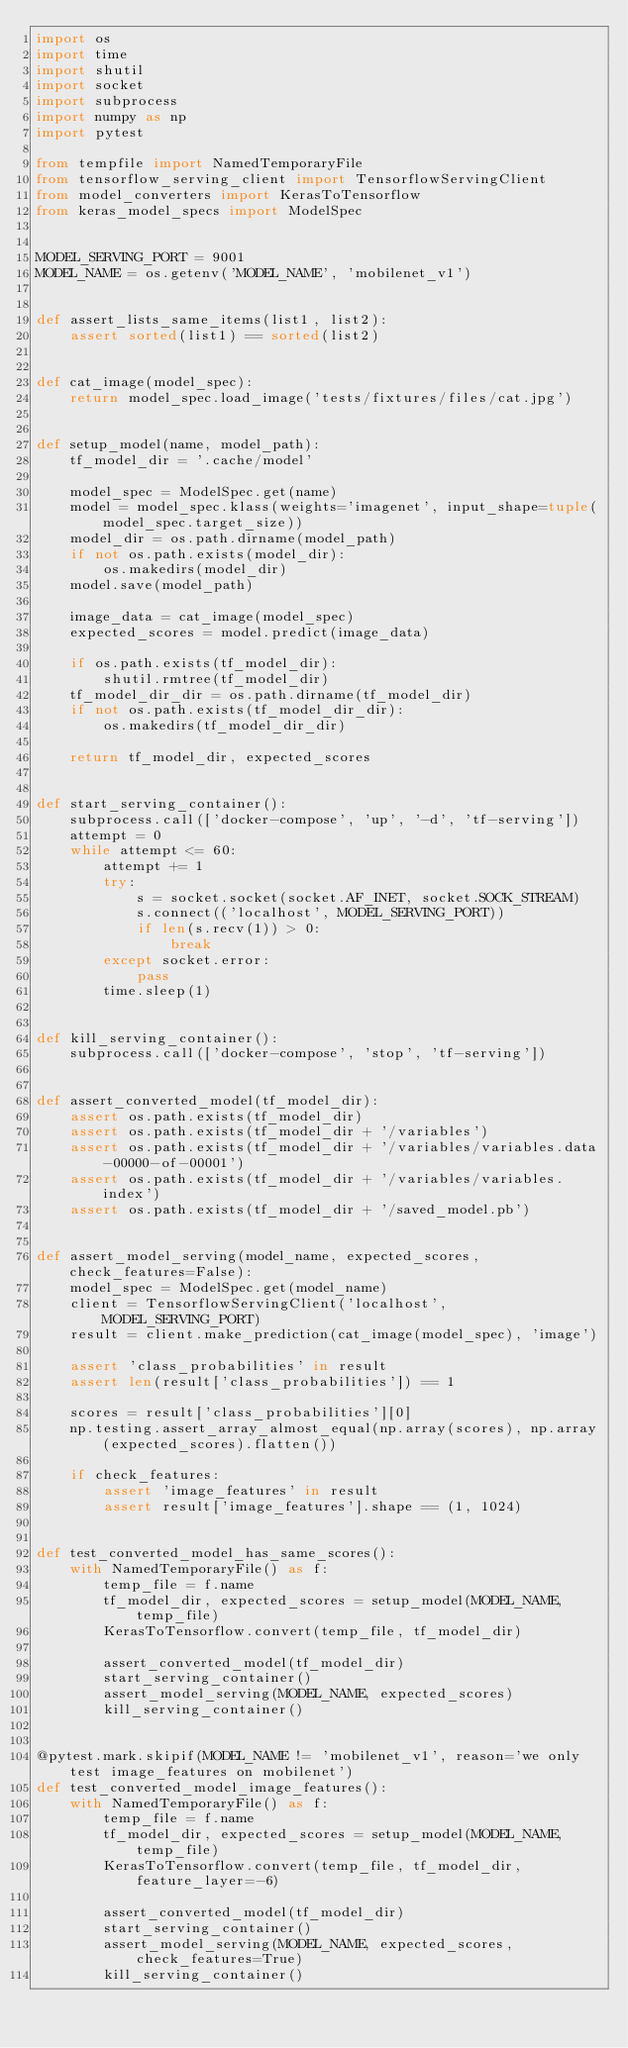<code> <loc_0><loc_0><loc_500><loc_500><_Python_>import os
import time
import shutil
import socket
import subprocess
import numpy as np
import pytest

from tempfile import NamedTemporaryFile
from tensorflow_serving_client import TensorflowServingClient
from model_converters import KerasToTensorflow
from keras_model_specs import ModelSpec


MODEL_SERVING_PORT = 9001
MODEL_NAME = os.getenv('MODEL_NAME', 'mobilenet_v1')


def assert_lists_same_items(list1, list2):
    assert sorted(list1) == sorted(list2)


def cat_image(model_spec):
    return model_spec.load_image('tests/fixtures/files/cat.jpg')


def setup_model(name, model_path):
    tf_model_dir = '.cache/model'

    model_spec = ModelSpec.get(name)
    model = model_spec.klass(weights='imagenet', input_shape=tuple(model_spec.target_size))
    model_dir = os.path.dirname(model_path)
    if not os.path.exists(model_dir):
        os.makedirs(model_dir)
    model.save(model_path)

    image_data = cat_image(model_spec)
    expected_scores = model.predict(image_data)

    if os.path.exists(tf_model_dir):
        shutil.rmtree(tf_model_dir)
    tf_model_dir_dir = os.path.dirname(tf_model_dir)
    if not os.path.exists(tf_model_dir_dir):
        os.makedirs(tf_model_dir_dir)

    return tf_model_dir, expected_scores


def start_serving_container():
    subprocess.call(['docker-compose', 'up', '-d', 'tf-serving'])
    attempt = 0
    while attempt <= 60:
        attempt += 1
        try:
            s = socket.socket(socket.AF_INET, socket.SOCK_STREAM)
            s.connect(('localhost', MODEL_SERVING_PORT))
            if len(s.recv(1)) > 0:
                break
        except socket.error:
            pass
        time.sleep(1)


def kill_serving_container():
    subprocess.call(['docker-compose', 'stop', 'tf-serving'])


def assert_converted_model(tf_model_dir):
    assert os.path.exists(tf_model_dir)
    assert os.path.exists(tf_model_dir + '/variables')
    assert os.path.exists(tf_model_dir + '/variables/variables.data-00000-of-00001')
    assert os.path.exists(tf_model_dir + '/variables/variables.index')
    assert os.path.exists(tf_model_dir + '/saved_model.pb')


def assert_model_serving(model_name, expected_scores, check_features=False):
    model_spec = ModelSpec.get(model_name)
    client = TensorflowServingClient('localhost', MODEL_SERVING_PORT)
    result = client.make_prediction(cat_image(model_spec), 'image')

    assert 'class_probabilities' in result
    assert len(result['class_probabilities']) == 1

    scores = result['class_probabilities'][0]
    np.testing.assert_array_almost_equal(np.array(scores), np.array(expected_scores).flatten())

    if check_features:
        assert 'image_features' in result
        assert result['image_features'].shape == (1, 1024)


def test_converted_model_has_same_scores():
    with NamedTemporaryFile() as f:
        temp_file = f.name
        tf_model_dir, expected_scores = setup_model(MODEL_NAME, temp_file)
        KerasToTensorflow.convert(temp_file, tf_model_dir)

        assert_converted_model(tf_model_dir)
        start_serving_container()
        assert_model_serving(MODEL_NAME, expected_scores)
        kill_serving_container()


@pytest.mark.skipif(MODEL_NAME != 'mobilenet_v1', reason='we only test image_features on mobilenet')
def test_converted_model_image_features():
    with NamedTemporaryFile() as f:
        temp_file = f.name
        tf_model_dir, expected_scores = setup_model(MODEL_NAME, temp_file)
        KerasToTensorflow.convert(temp_file, tf_model_dir, feature_layer=-6)

        assert_converted_model(tf_model_dir)
        start_serving_container()
        assert_model_serving(MODEL_NAME, expected_scores, check_features=True)
        kill_serving_container()
</code> 